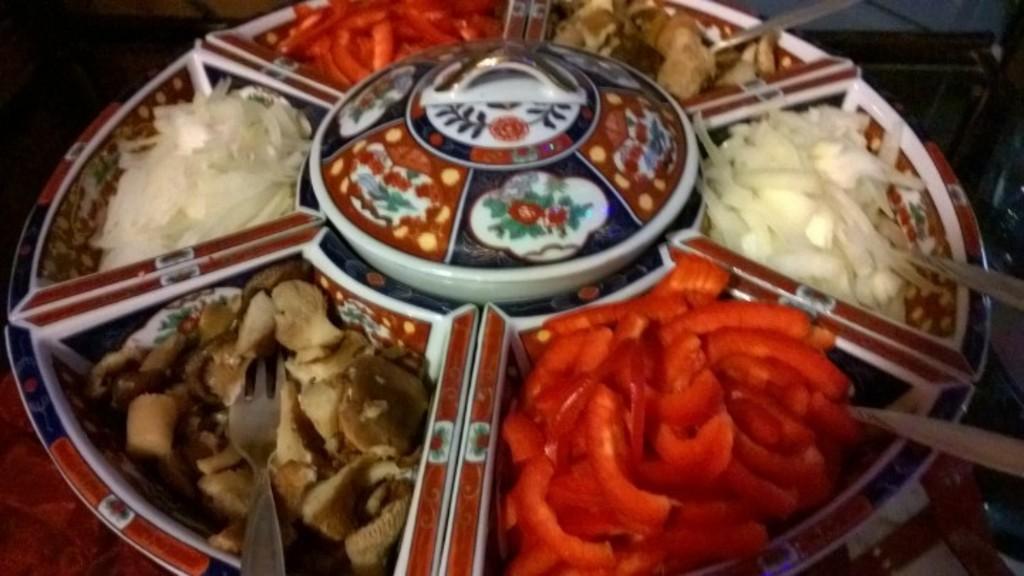Please provide a concise description of this image. In the center of the image, we can see food items and spoons and a fork are on the plate. At the bottom, there is table. 